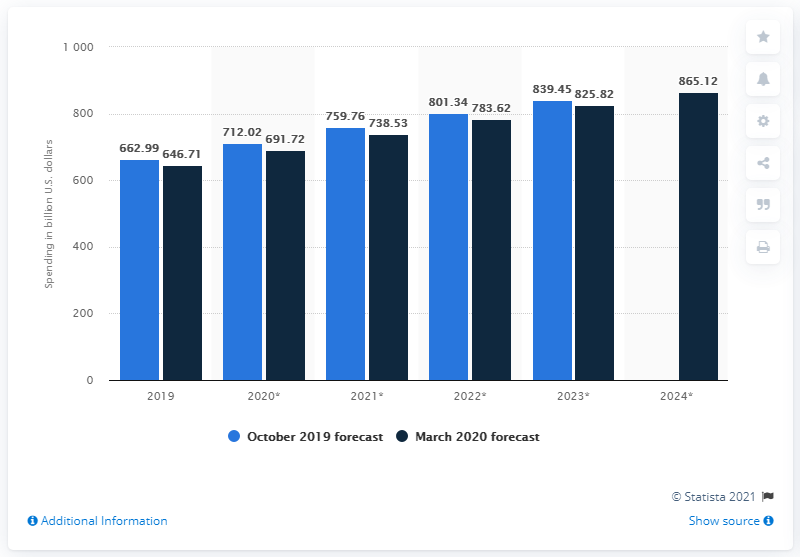Identify some key points in this picture. The forecast for October 2019 is expected to be [insert numerical value]. The difference between the two forecasts in 2020 is that one predicts 20.3, while the other predicts 20.3. According to projections, global media spending is expected to reach a total of 691.72 U.S. dollars in 2020. 